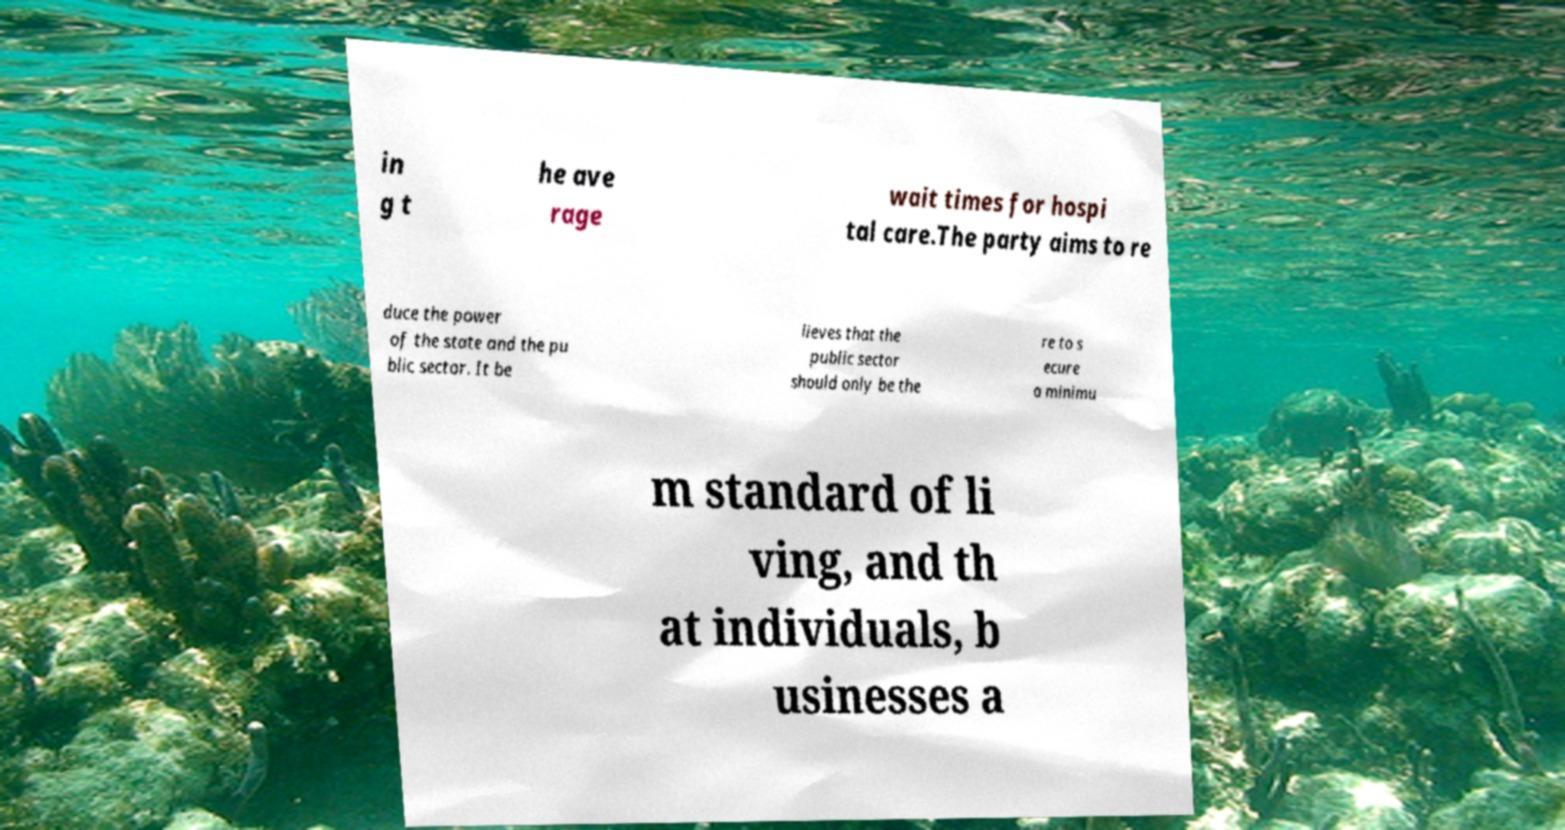There's text embedded in this image that I need extracted. Can you transcribe it verbatim? in g t he ave rage wait times for hospi tal care.The party aims to re duce the power of the state and the pu blic sector. It be lieves that the public sector should only be the re to s ecure a minimu m standard of li ving, and th at individuals, b usinesses a 